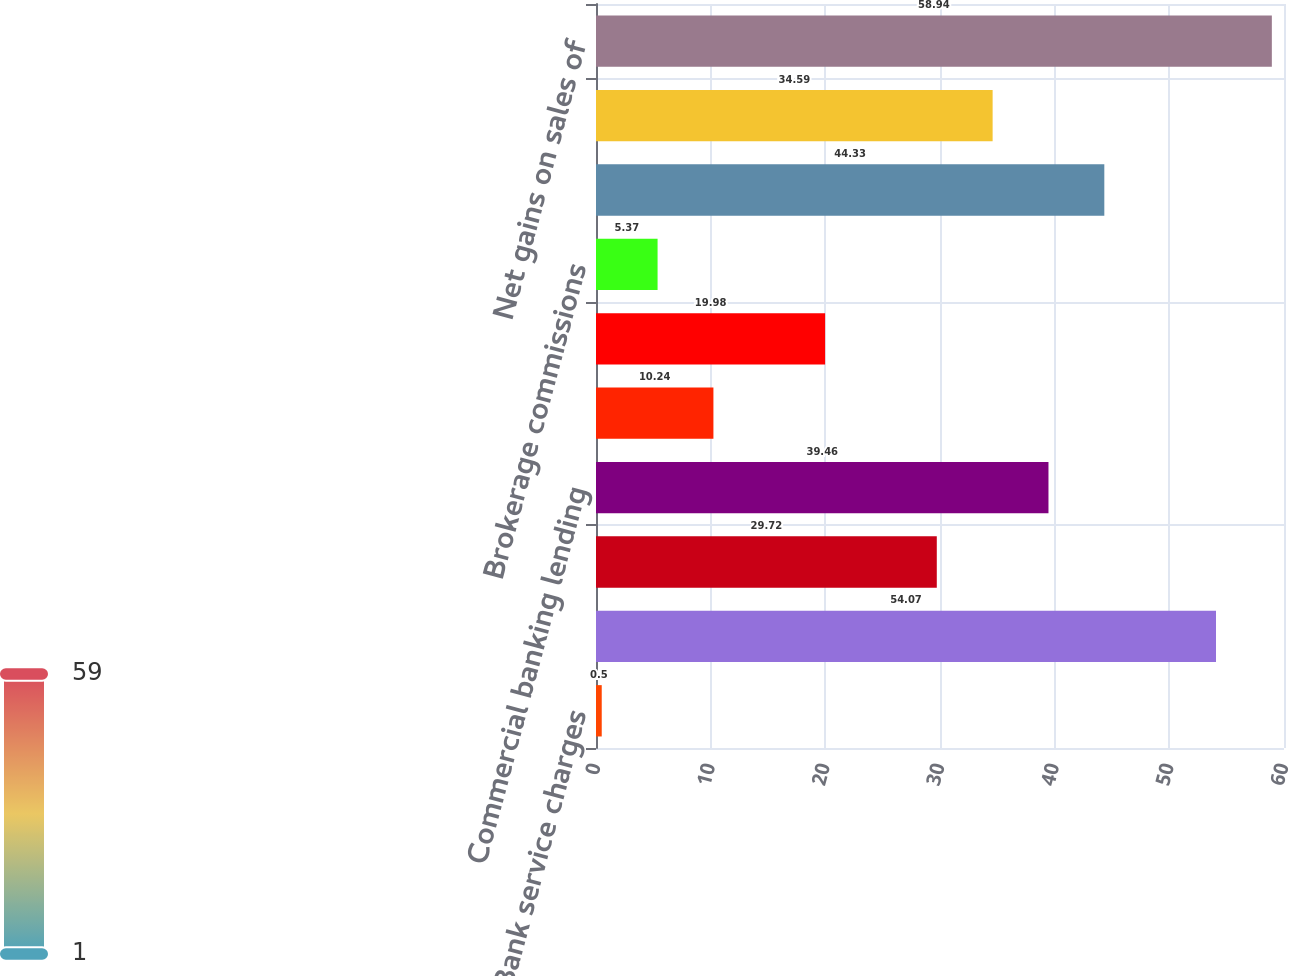<chart> <loc_0><loc_0><loc_500><loc_500><bar_chart><fcel>Bank service charges<fcel>Investment management fees<fcel>Operating lease income<fcel>Commercial banking lending<fcel>Insurance revenue<fcel>Cash management fees<fcel>Brokerage commissions<fcel>Customer interest rate swap<fcel>BOLI<fcel>Net gains on sales of<nl><fcel>0.5<fcel>54.07<fcel>29.72<fcel>39.46<fcel>10.24<fcel>19.98<fcel>5.37<fcel>44.33<fcel>34.59<fcel>58.94<nl></chart> 